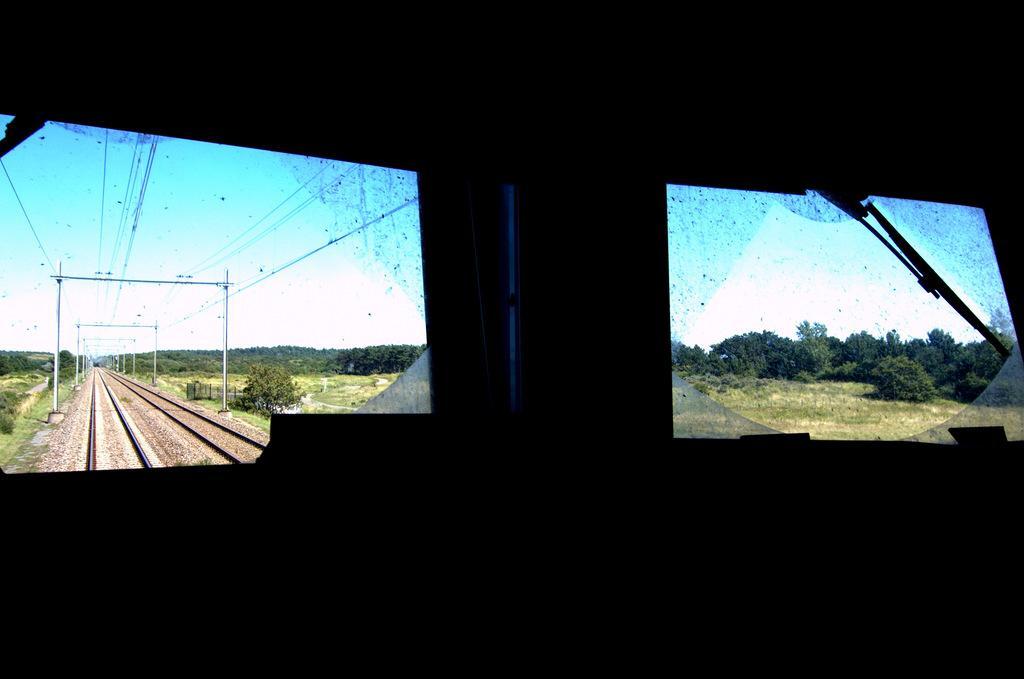In one or two sentences, can you explain what this image depicts? In this image in the front there are windows, behind the windows there are trees, there is grass and there are railway tracks, there are poles and there are wires attached to the poles. 